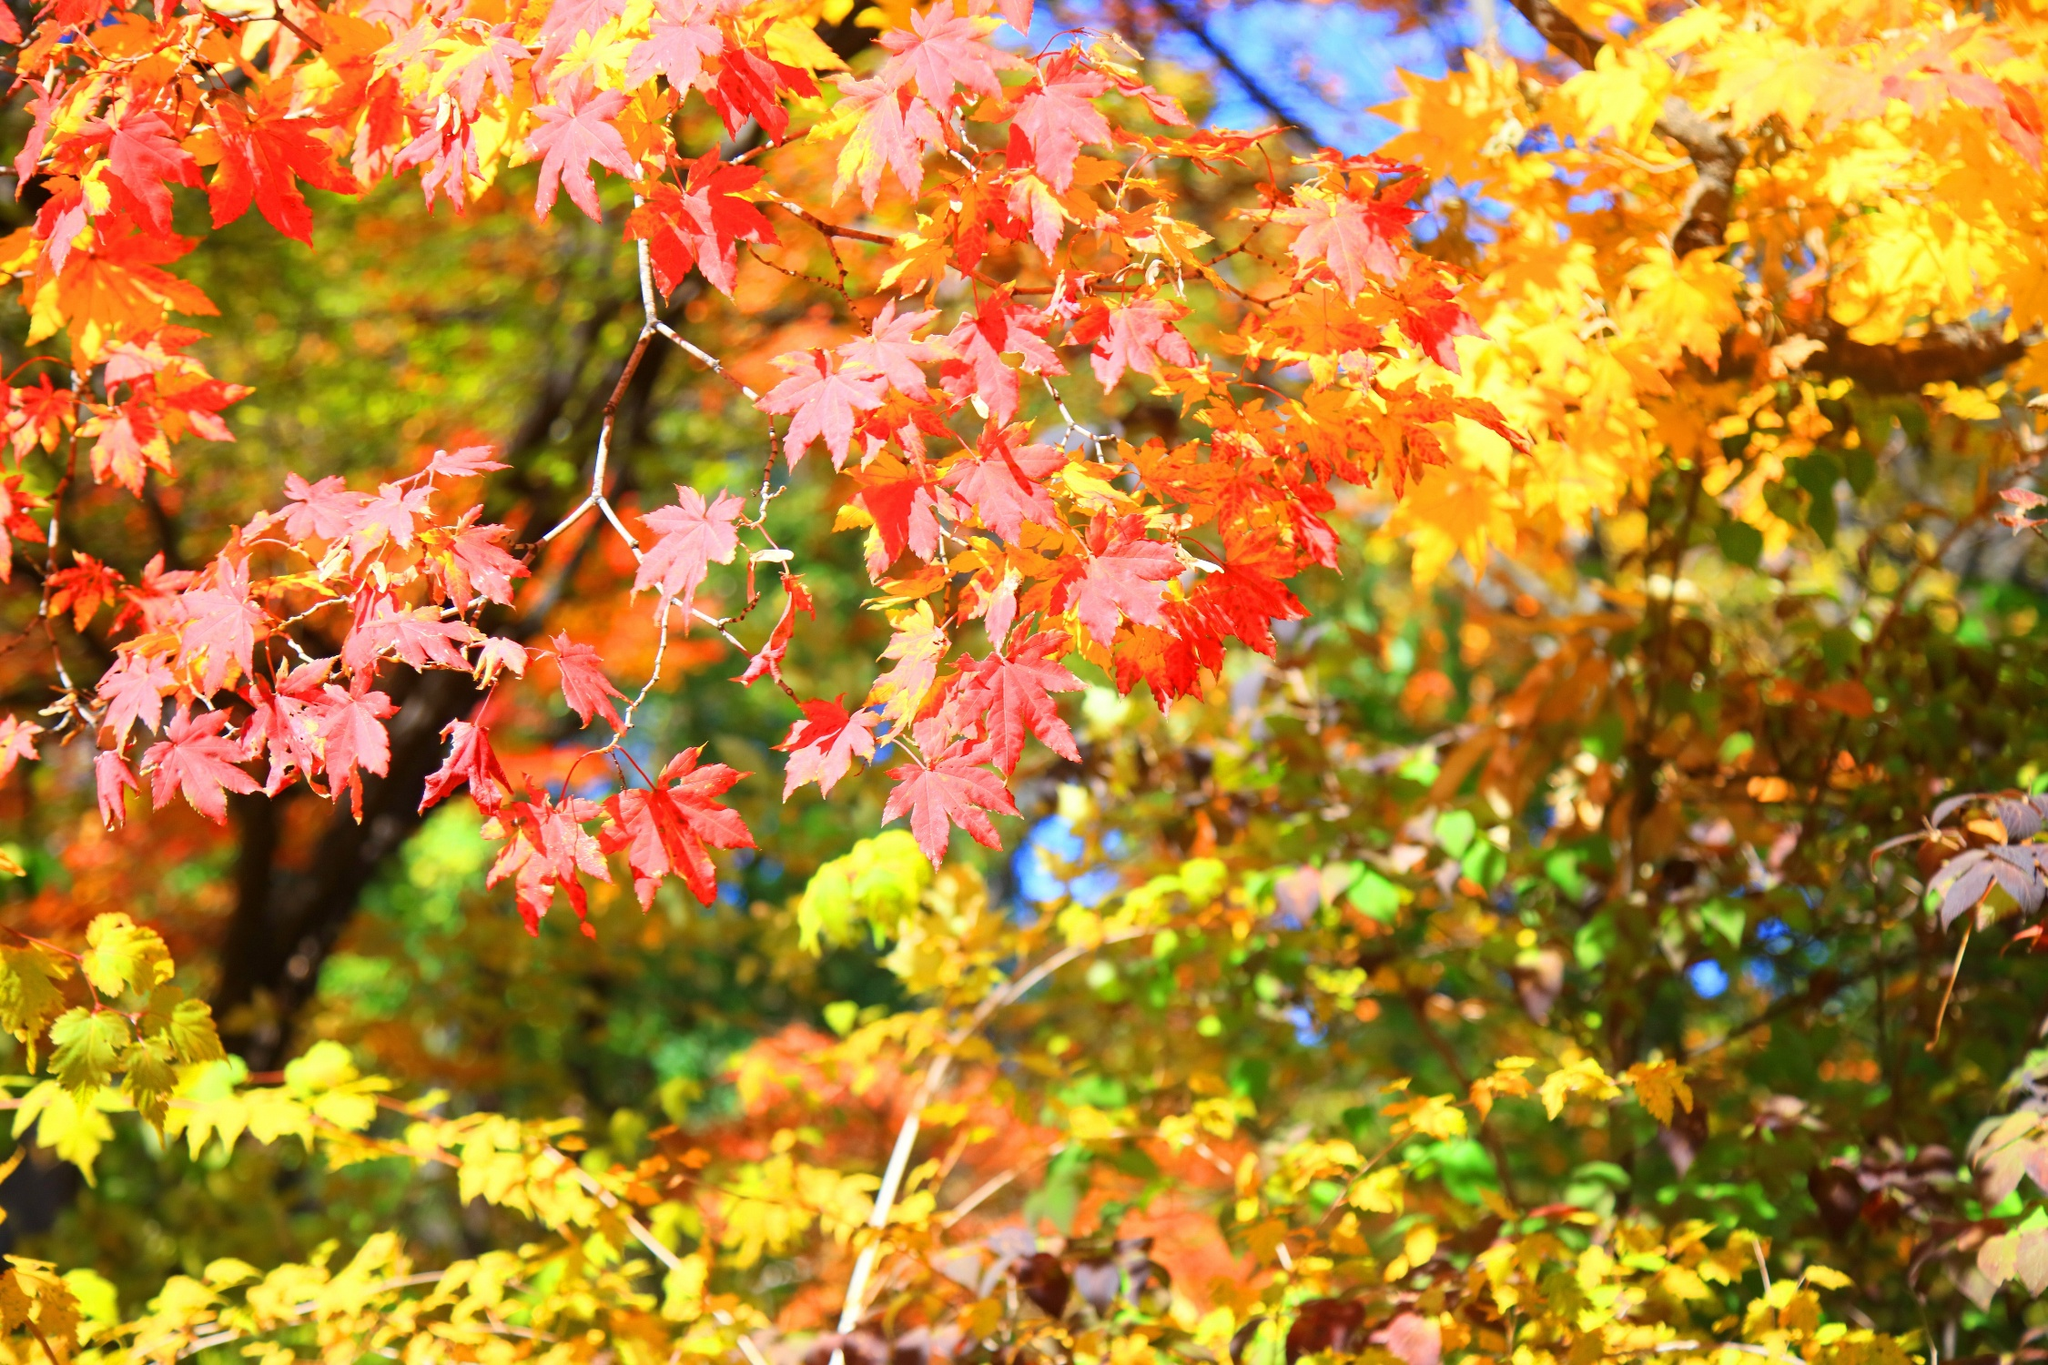How does this image convey the feeling of autumn? This image encapsulates the feeling of autumn through its vibrant display of fall foliage in hues of red, orange, and yellow. The warm colors evoke a sense of coziness and nostalgia associated with the season. The interplay of light and shadow creates a dynamic yet serene atmosphere, reminiscent of a sunny fall day. The overall composition, with leaves foregrounded in sharp focus and the blurred background, adds depth and emphasizes the richness of autumn. The trees in the distance, equally adorned in autumn colors, enhance the scene's completeness, encapsulating the essence of the season's beauty. Why might artists be drawn to scenes like this? Artists are often drawn to scenes like this for several reasons. The vivid and varied colors of autumn leaves offer a rich palette to work with, allowing for expressive and dynamic compositions. The interplay of light and shadow during fall can create dramatic effects that lend depth and interest to a piece. Additionally, the nostalgic and serene qualities of autumn scenes can evoke strong emotions, making them compelling subjects for artistic expression. Nature's cyclical beauty, as depicted in the changing seasons, inspires reflection and creativity, encouraging artists to capture its essence in their unique styles. 